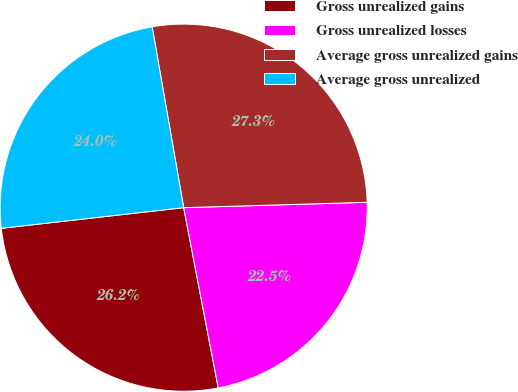<chart> <loc_0><loc_0><loc_500><loc_500><pie_chart><fcel>Gross unrealized gains<fcel>Gross unrealized losses<fcel>Average gross unrealized gains<fcel>Average gross unrealized<nl><fcel>26.22%<fcel>22.45%<fcel>27.28%<fcel>24.05%<nl></chart> 